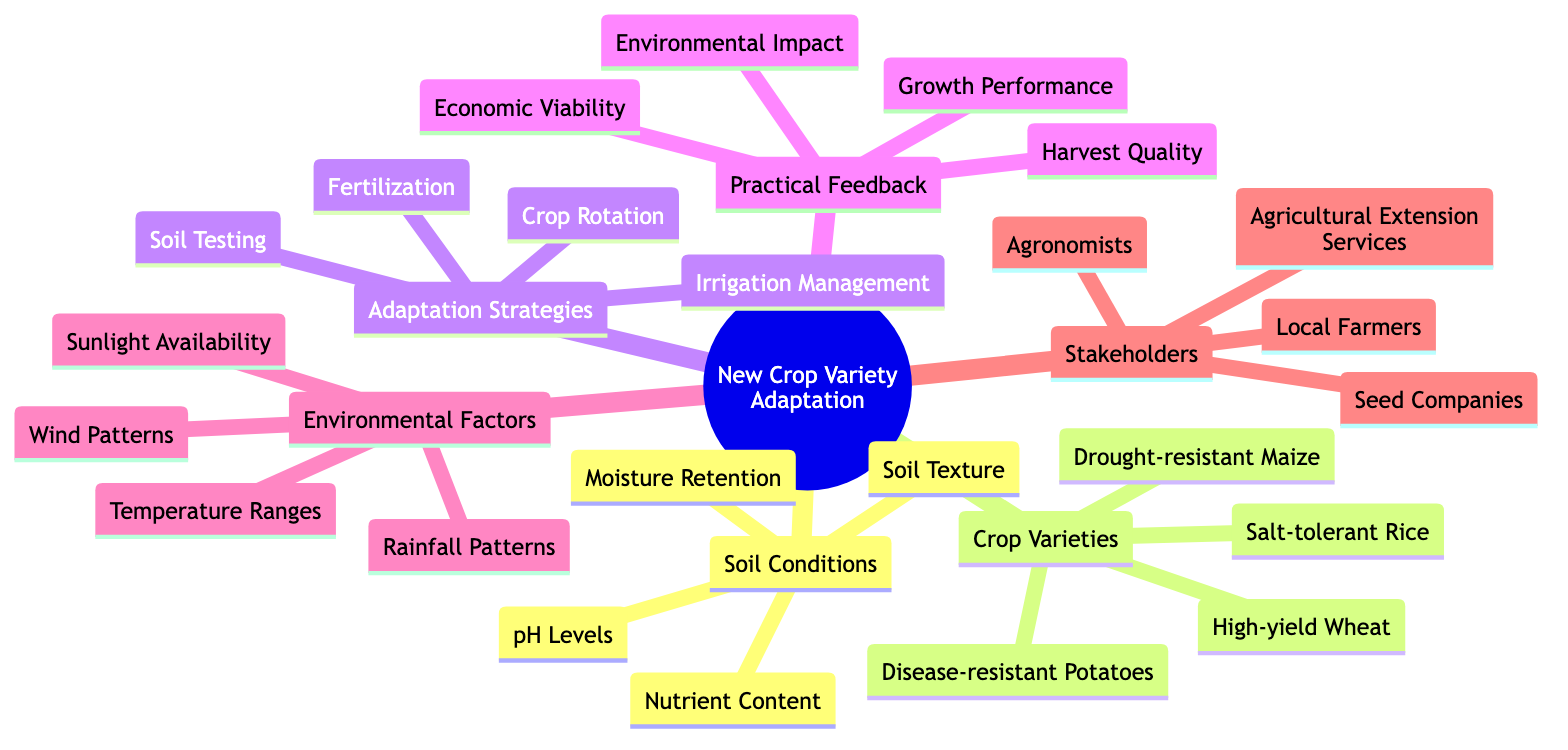What are the components of Soil Conditions? The diagram specifies that under "Soil Conditions," there are four components listed: Soil Texture, pH Levels, Nutrient Content, and Moisture Retention.
Answer: Soil Texture, pH Levels, Nutrient Content, Moisture Retention How many types of Crop Varieties are indicated? The diagram lists four examples of Crop Varieties, which are Drought-resistant Maize, High-yield Wheat, Disease-resistant Potatoes, and Salt-tolerant Rice.
Answer: 4 What adaptation strategy focuses on assessing soil properties? The diagram shows "Soil Testing" as one of the Adaptation Strategies that is specifically dedicated to assessing properties related to soil.
Answer: Soil Testing Which stakeholders are involved in crop variety adaptation? The diagram identifies four groups of stakeholders: Local Farmers, Agronomists, Agricultural Extension Services, and Seed Companies that play a role in the adaptation process.
Answer: Local Farmers, Agronomists, Agricultural Extension Services, Seed Companies What factors comprise Environmental Factors in the diagram? According to the diagram, Environmental Factors consist of Rainfall Patterns, Temperature Ranges, Sunlight Availability, and Wind Patterns, demonstrating the range of climatic impacts on crop adaptation.
Answer: Rainfall Patterns, Temperature Ranges, Sunlight Availability, Wind Patterns How can you explain the relationship between Crop Varieties and Practical Feedback? The diagram implies that Practical Feedback regarding crop performance evaluates several attributes of Crop Varieties, such as Growth Performance, Harvest Quality, Economic Viability, and Environmental Impact. This interconnection underscores how chosen crop varieties directly affect feedback metrics.
Answer: They evaluate attributes of crop varieties Which adaptation strategy may improve water management? The diagram specifies "Irrigation Management" as an adaptation strategy that focuses primarily on optimizing water usage for crops, which is crucial in varying soil conditions.
Answer: Irrigation Management Which crop variety is likely to perform well in saline conditions? The diagram indicates that Salt-tolerant Rice is the crop variety specifically designed to withstand saline soil conditions, showcasing its major characteristic of adaptation.
Answer: Salt-tolerant Rice What is the purpose of Fertilization as an adaptation strategy? The diagram lists "Fertilization" under Adaptation Strategies, indicating that it enhances nutrient availability in the soil to improve crop growth and yield under specific soil conditions.
Answer: Enhance nutrient availability in soil 